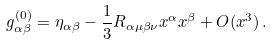Convert formula to latex. <formula><loc_0><loc_0><loc_500><loc_500>g ^ { ( 0 ) } _ { \alpha \beta } = \eta _ { \alpha \beta } - \frac { 1 } { 3 } R _ { \alpha \mu \beta \nu } x ^ { \alpha } x ^ { \beta } + O ( x ^ { 3 } ) \, .</formula> 